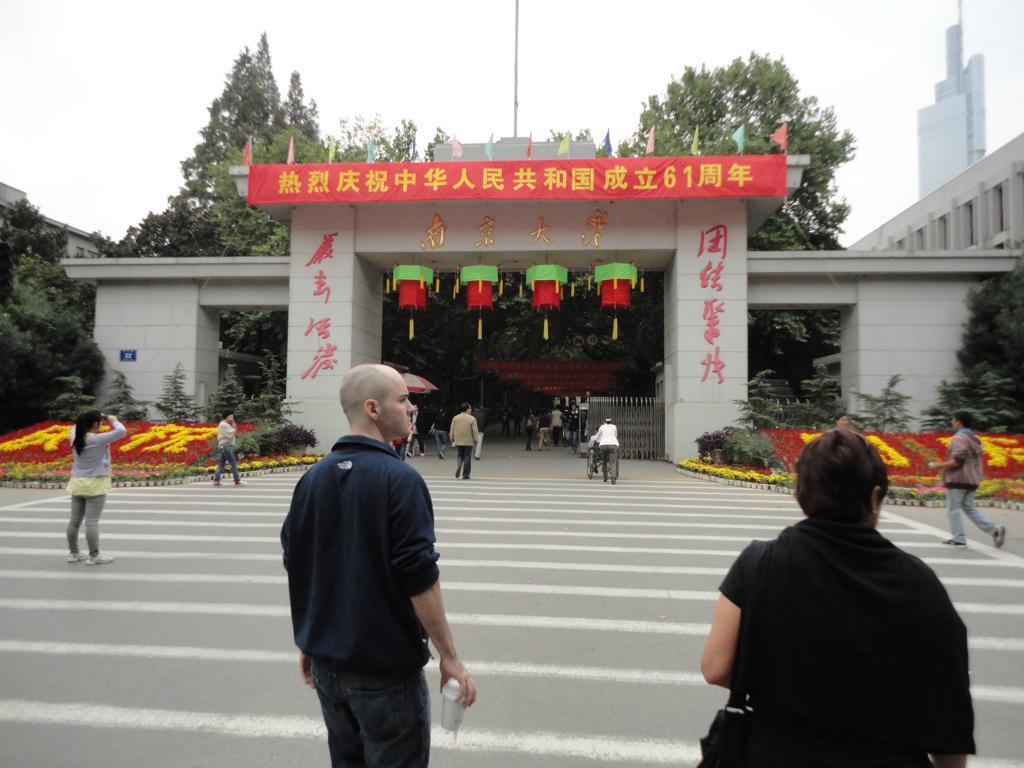Please provide a concise description of this image. In this image we can see one pole, some buildings, so many trees, plants, some flags, some plants with flowers, one blue board attached to the wall, one tent, one red color banner with some text, some text on the wall, some objects attached to the ceiling, some people walking on the road and at the top there is the sky. Some people are holding some objects. 